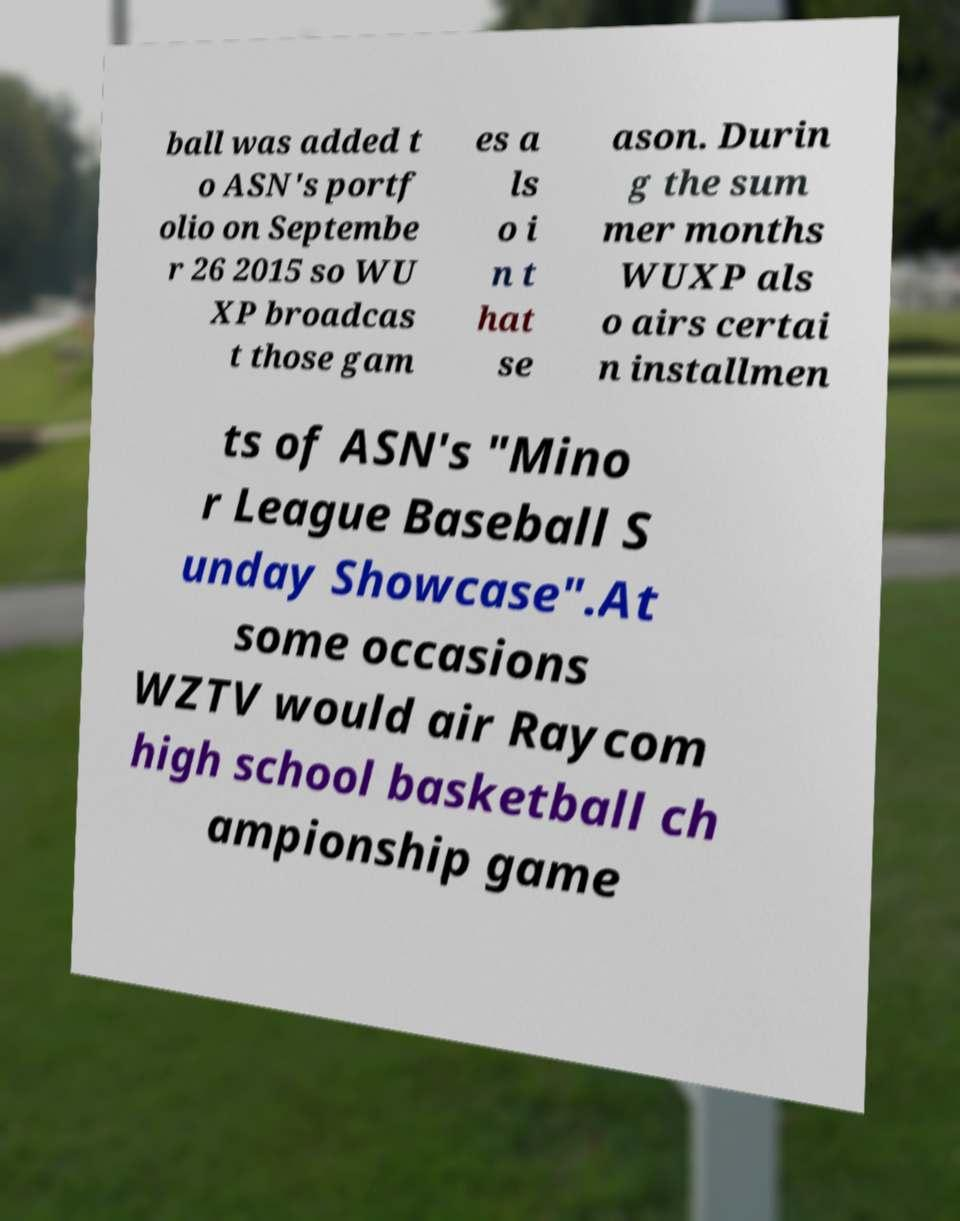Can you accurately transcribe the text from the provided image for me? ball was added t o ASN's portf olio on Septembe r 26 2015 so WU XP broadcas t those gam es a ls o i n t hat se ason. Durin g the sum mer months WUXP als o airs certai n installmen ts of ASN's "Mino r League Baseball S unday Showcase".At some occasions WZTV would air Raycom high school basketball ch ampionship game 